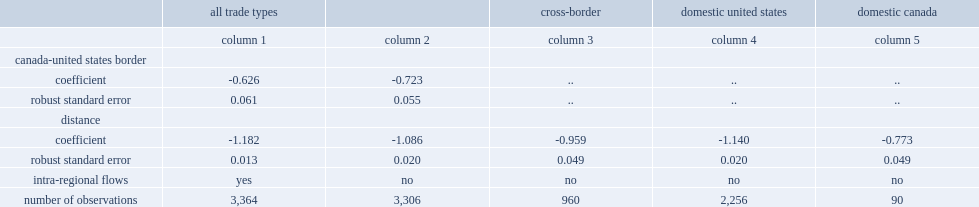What was the trade elasticity of distance for united states domestic trade? -1.14. What was the trade elasticity of distance for canadian domestic trade? -0.773. What was the cross-border trade's distance elasticity which is close to unity, as is often found in the international trade literature? -0.959. 